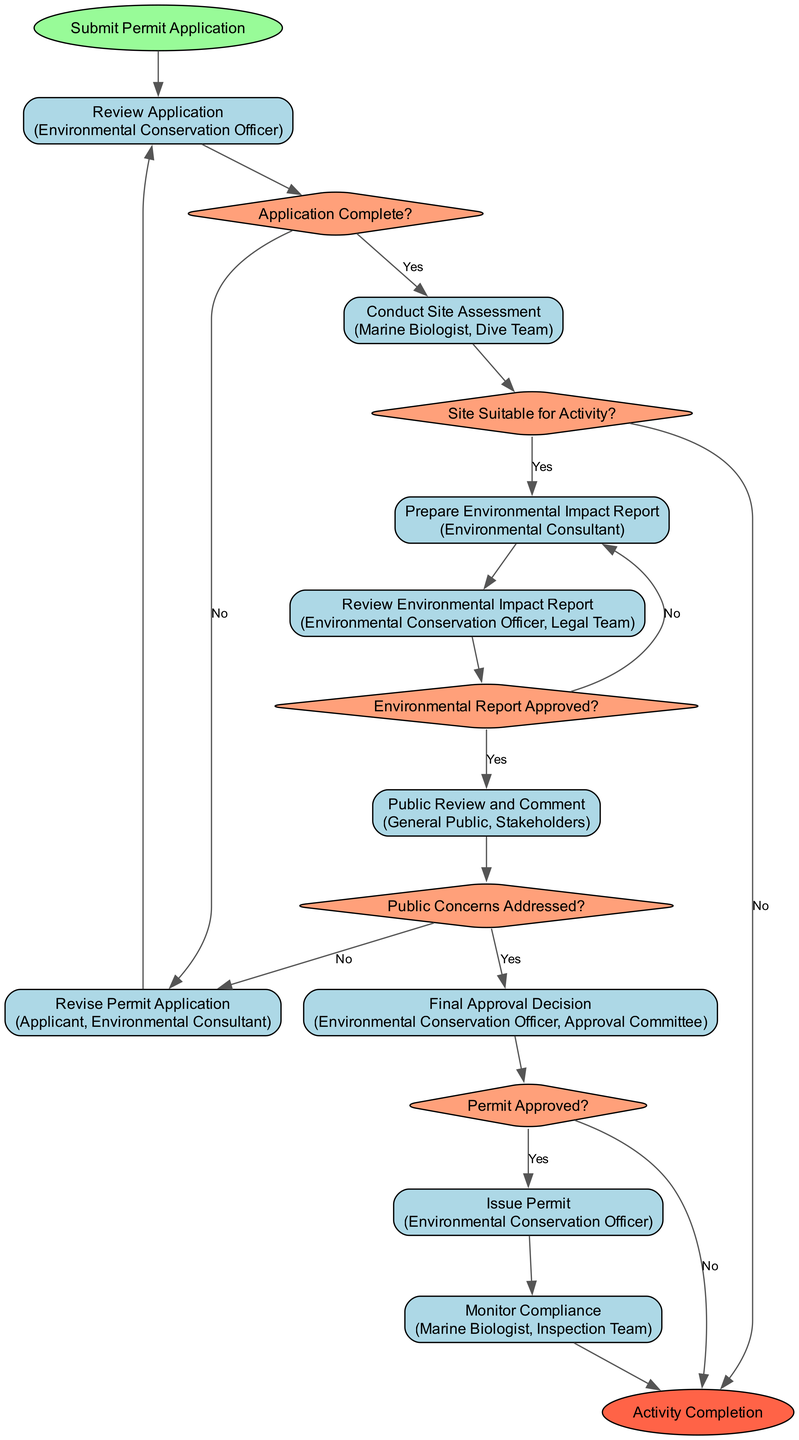What is the starting point of the workflow? The workflow begins with the submission of a permit application as indicated by the "Submit Permit Application" node.
Answer: Submit Permit Application How many activities are there in the workflow? By counting the activity nodes listed, there are a total of 6 activities: Review Application, Conduct Site Assessment, Prepare Environmental Impact Report, Review Environmental Impact Report, Public Review and Comment, and Issue Permit.
Answer: 6 What role is involved in reviewing the environmental impact report? The node "Review Environmental Impact Report" includes both the Environmental Conservation Officer and the Legal Team as responsible roles for this task.
Answer: Environmental Conservation Officer, Legal Team What happens if the application is incomplete? If the application is found to be incomplete, the flow moves to the "Revise Permit Application" node, where the applicant and the environmental consultant are involved in revising the application before resubmitting it for review.
Answer: Revise Permit Application What decision follows the site assessment? Following the "Conduct Site Assessment" activity, the next decision is whether the site is suitable for activity, which is indicated in the diagram by the "Site Suitable for Activity?" node.
Answer: Site Suitable for Activity? If the environmental report is not approved, where does the workflow go next? If the environmental report is not approved, the workflow returns to the "Prepare Environmental Impact Report" node, indicating that the report needs to be revised before further process.
Answer: Prepare Environmental Impact Report Which roles are responsible for monitoring compliance after the permit is issued? The roles responsible for monitoring compliance are the Marine Biologist and the Inspection Team as stated in the "Monitor Compliance" activity node.
Answer: Marine Biologist, Inspection Team What is the final decision point in the workflow regarding the permit? The final decision point is labeled "Permit Approved?", which determines whether the permit can be issued based on the previous steps and evaluations made throughout the process.
Answer: Permit Approved? What is indicated by the "Public Concerns Addressed?" decision? This decision evaluates whether any public concerns regarding the permit application have been satisfactorily addressed, which impacts the next steps leading to final decision making.
Answer: Public Concerns Addressed? 